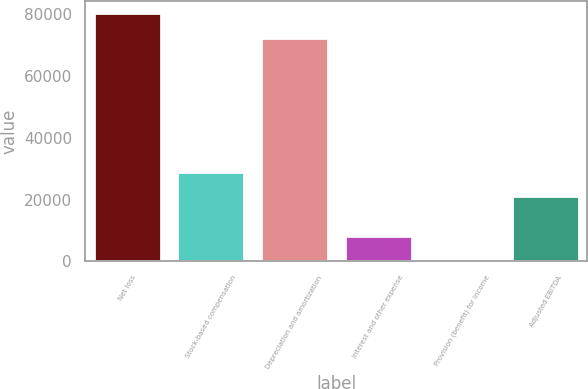Convert chart to OTSL. <chart><loc_0><loc_0><loc_500><loc_500><bar_chart><fcel>Net loss<fcel>Stock-based compensation<fcel>Depreciation and amortization<fcel>Interest and other expense<fcel>Provision (benefit) for income<fcel>Adjusted EBITDA<nl><fcel>80423<fcel>29081<fcel>72506<fcel>8146<fcel>229<fcel>21164<nl></chart> 